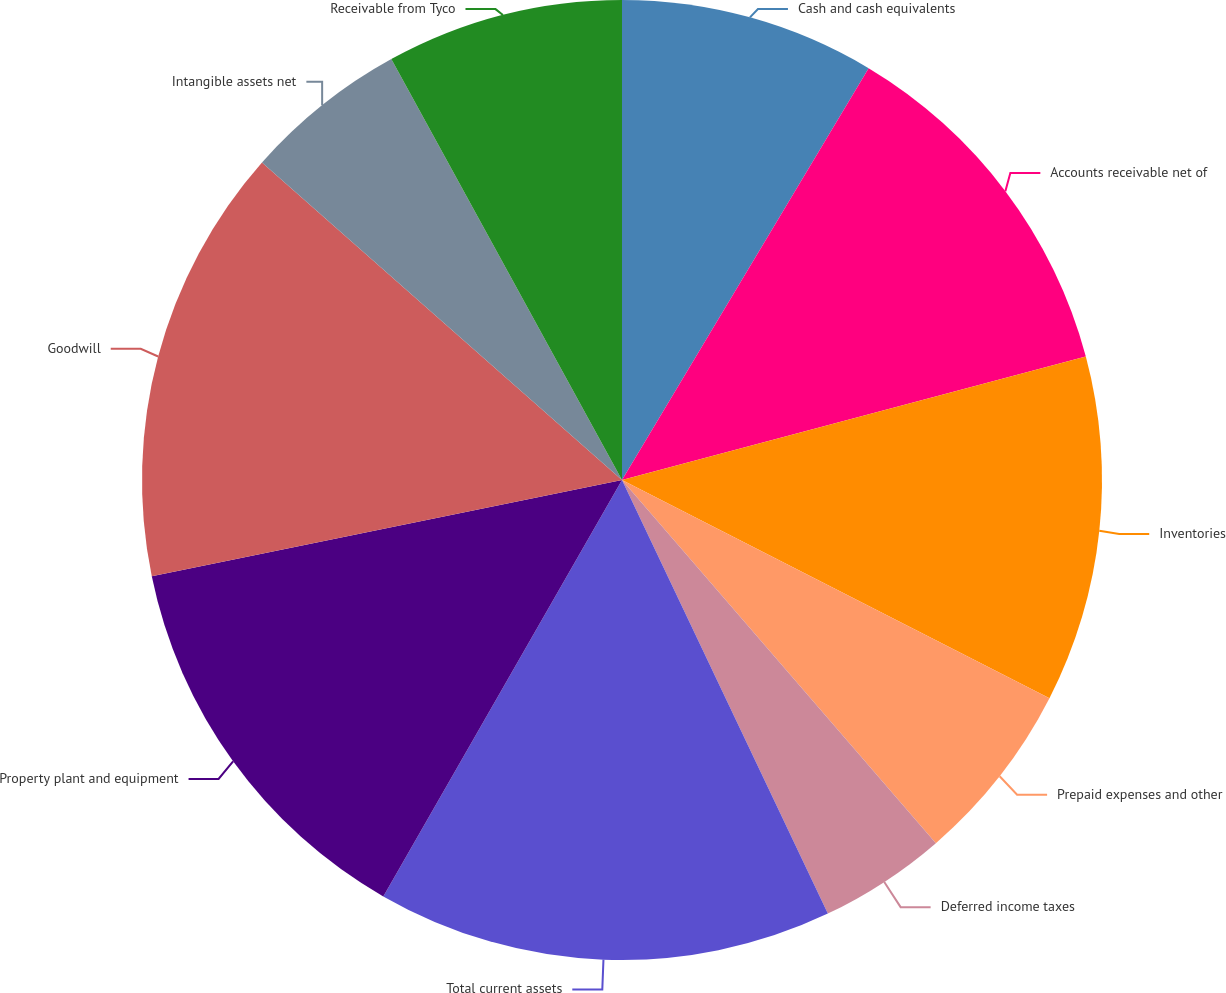Convert chart to OTSL. <chart><loc_0><loc_0><loc_500><loc_500><pie_chart><fcel>Cash and cash equivalents<fcel>Accounts receivable net of<fcel>Inventories<fcel>Prepaid expenses and other<fcel>Deferred income taxes<fcel>Total current assets<fcel>Property plant and equipment<fcel>Goodwill<fcel>Intangible assets net<fcel>Receivable from Tyco<nl><fcel>8.59%<fcel>12.27%<fcel>11.66%<fcel>6.14%<fcel>4.29%<fcel>15.34%<fcel>13.5%<fcel>14.72%<fcel>5.52%<fcel>7.98%<nl></chart> 